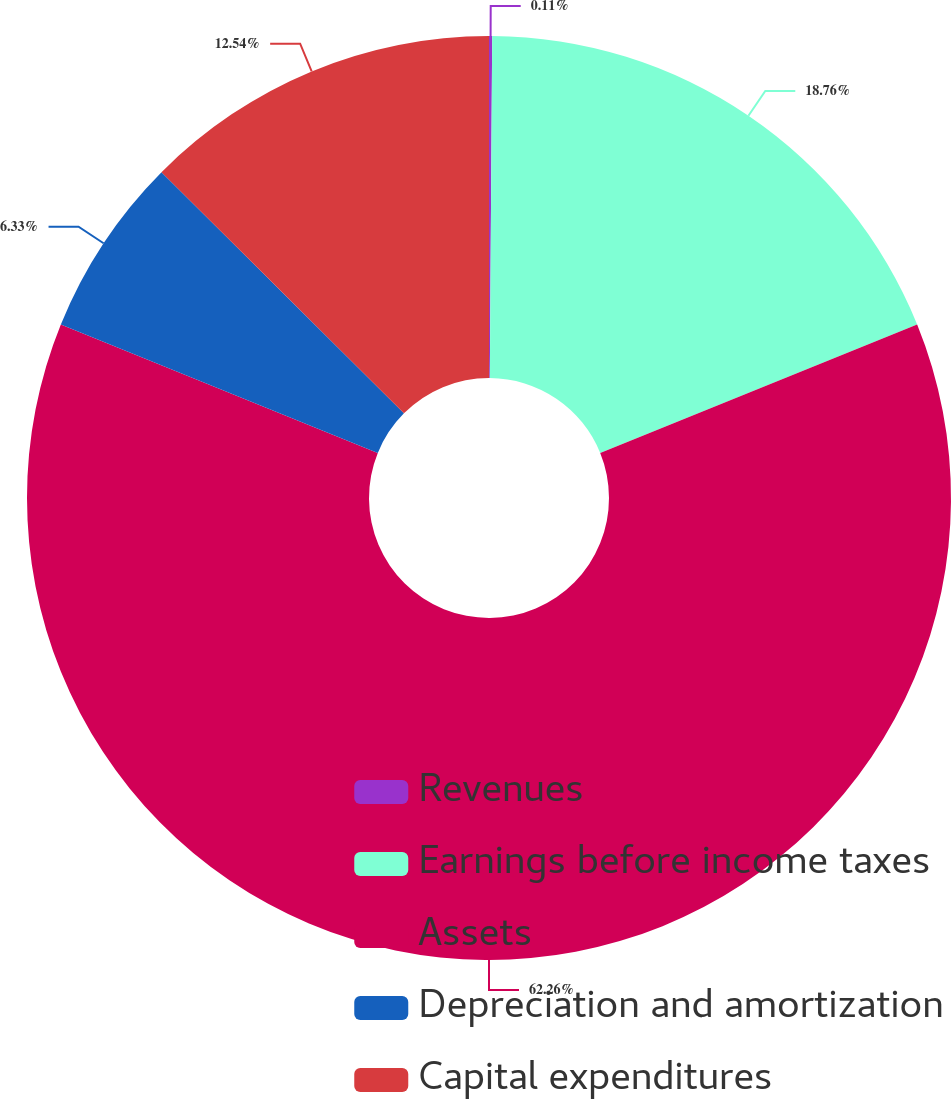<chart> <loc_0><loc_0><loc_500><loc_500><pie_chart><fcel>Revenues<fcel>Earnings before income taxes<fcel>Assets<fcel>Depreciation and amortization<fcel>Capital expenditures<nl><fcel>0.11%<fcel>18.76%<fcel>62.26%<fcel>6.33%<fcel>12.54%<nl></chart> 